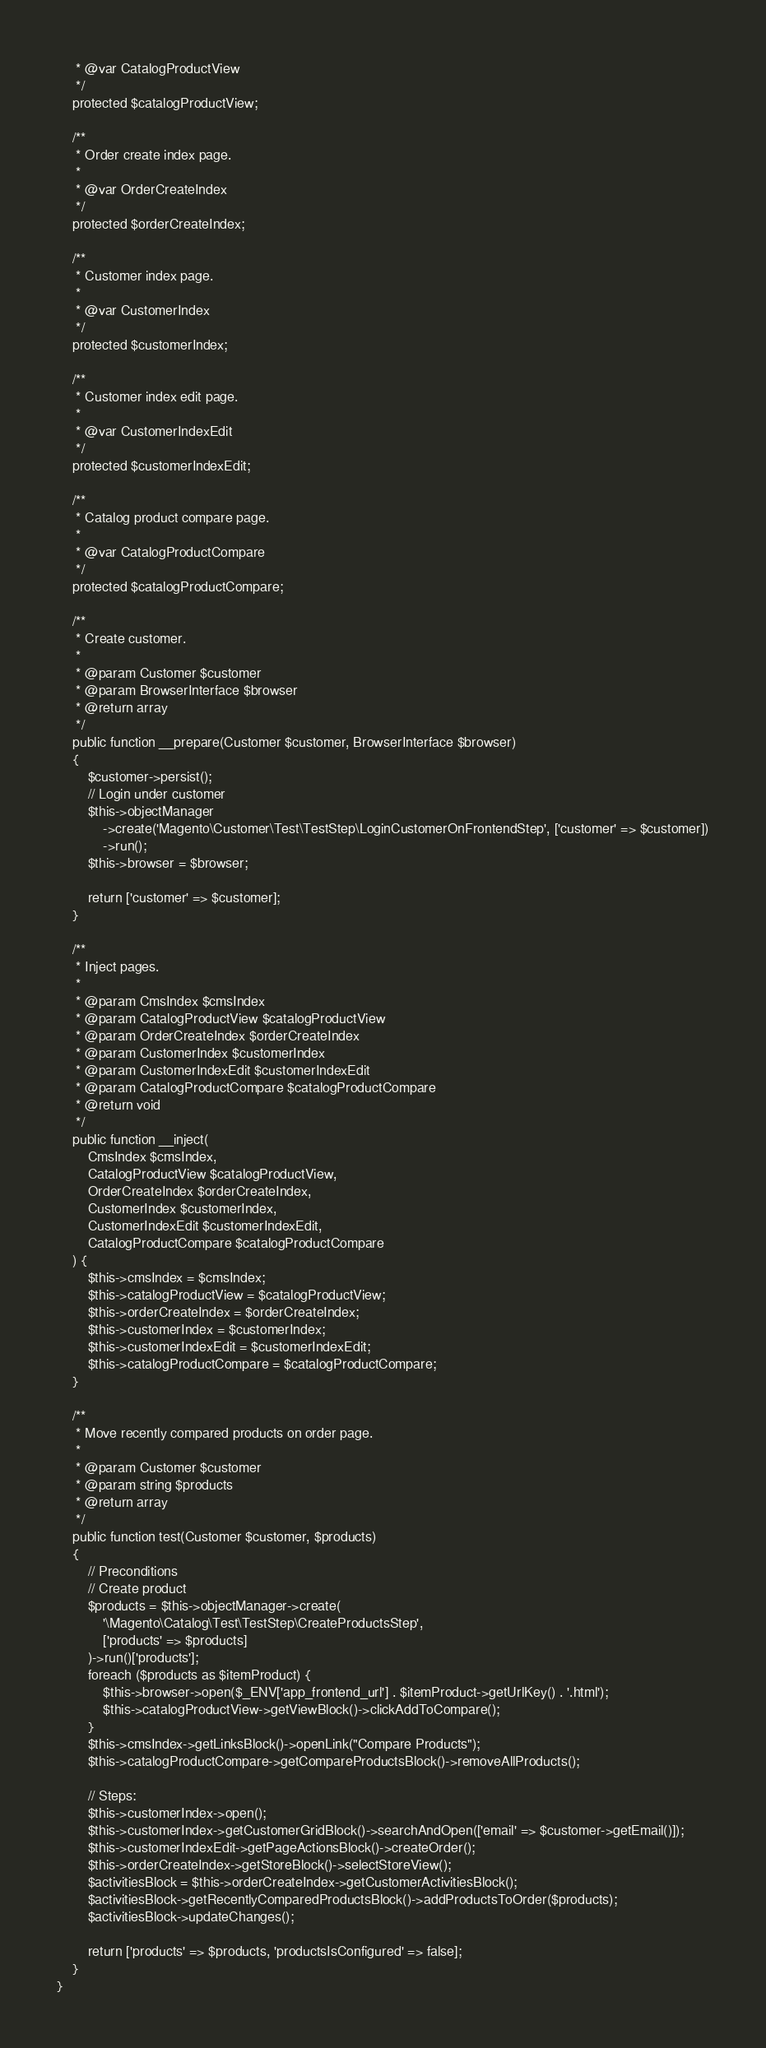Convert code to text. <code><loc_0><loc_0><loc_500><loc_500><_PHP_>     * @var CatalogProductView
     */
    protected $catalogProductView;

    /**
     * Order create index page.
     *
     * @var OrderCreateIndex
     */
    protected $orderCreateIndex;

    /**
     * Customer index page.
     *
     * @var CustomerIndex
     */
    protected $customerIndex;

    /**
     * Customer index edit page.
     *
     * @var CustomerIndexEdit
     */
    protected $customerIndexEdit;

    /**
     * Catalog product compare page.
     *
     * @var CatalogProductCompare
     */
    protected $catalogProductCompare;

    /**
     * Create customer.
     *
     * @param Customer $customer
     * @param BrowserInterface $browser
     * @return array
     */
    public function __prepare(Customer $customer, BrowserInterface $browser)
    {
        $customer->persist();
        // Login under customer
        $this->objectManager
            ->create('Magento\Customer\Test\TestStep\LoginCustomerOnFrontendStep', ['customer' => $customer])
            ->run();
        $this->browser = $browser;

        return ['customer' => $customer];
    }

    /**
     * Inject pages.
     *
     * @param CmsIndex $cmsIndex
     * @param CatalogProductView $catalogProductView
     * @param OrderCreateIndex $orderCreateIndex
     * @param CustomerIndex $customerIndex
     * @param CustomerIndexEdit $customerIndexEdit
     * @param CatalogProductCompare $catalogProductCompare
     * @return void
     */
    public function __inject(
        CmsIndex $cmsIndex,
        CatalogProductView $catalogProductView,
        OrderCreateIndex $orderCreateIndex,
        CustomerIndex $customerIndex,
        CustomerIndexEdit $customerIndexEdit,
        CatalogProductCompare $catalogProductCompare
    ) {
        $this->cmsIndex = $cmsIndex;
        $this->catalogProductView = $catalogProductView;
        $this->orderCreateIndex = $orderCreateIndex;
        $this->customerIndex = $customerIndex;
        $this->customerIndexEdit = $customerIndexEdit;
        $this->catalogProductCompare = $catalogProductCompare;
    }

    /**
     * Move recently compared products on order page.
     *
     * @param Customer $customer
     * @param string $products
     * @return array
     */
    public function test(Customer $customer, $products)
    {
        // Preconditions
        // Create product
        $products = $this->objectManager->create(
            '\Magento\Catalog\Test\TestStep\CreateProductsStep',
            ['products' => $products]
        )->run()['products'];
        foreach ($products as $itemProduct) {
            $this->browser->open($_ENV['app_frontend_url'] . $itemProduct->getUrlKey() . '.html');
            $this->catalogProductView->getViewBlock()->clickAddToCompare();
        }
        $this->cmsIndex->getLinksBlock()->openLink("Compare Products");
        $this->catalogProductCompare->getCompareProductsBlock()->removeAllProducts();

        // Steps:
        $this->customerIndex->open();
        $this->customerIndex->getCustomerGridBlock()->searchAndOpen(['email' => $customer->getEmail()]);
        $this->customerIndexEdit->getPageActionsBlock()->createOrder();
        $this->orderCreateIndex->getStoreBlock()->selectStoreView();
        $activitiesBlock = $this->orderCreateIndex->getCustomerActivitiesBlock();
        $activitiesBlock->getRecentlyComparedProductsBlock()->addProductsToOrder($products);
        $activitiesBlock->updateChanges();

        return ['products' => $products, 'productsIsConfigured' => false];
    }
}
</code> 